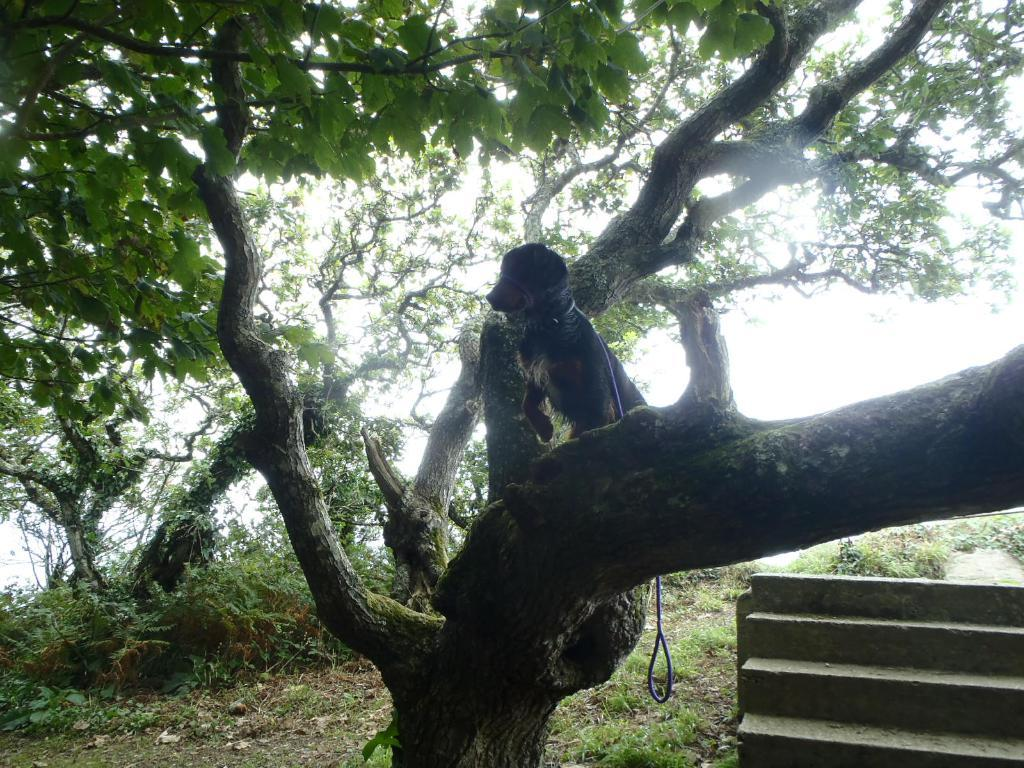What animal can be seen in the image? There is a dog in the image. Where is the dog located in the image? The dog is standing on a branch in the image. What type of accessory is visible in the image? There is a dog belt visible in the image. What type of plant is present in the image? The image contains a tree with branches and leaves, as well as small bushes. Are there any architectural features in the image? Yes, there are stairs in the image. What type of club can be seen in the image? There is no club present in the image; it features a dog standing on a branch with a dog belt. What type of plate is being used by the dog in the image? There is no plate present in the image, and the dog is not using any plate. 